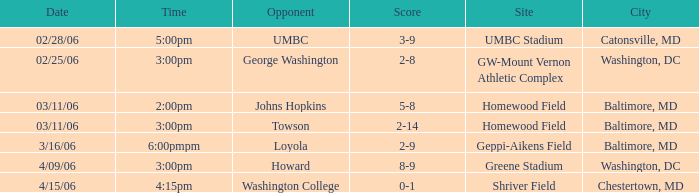Who is the Opponent when the Score is 2-8? George Washington. 